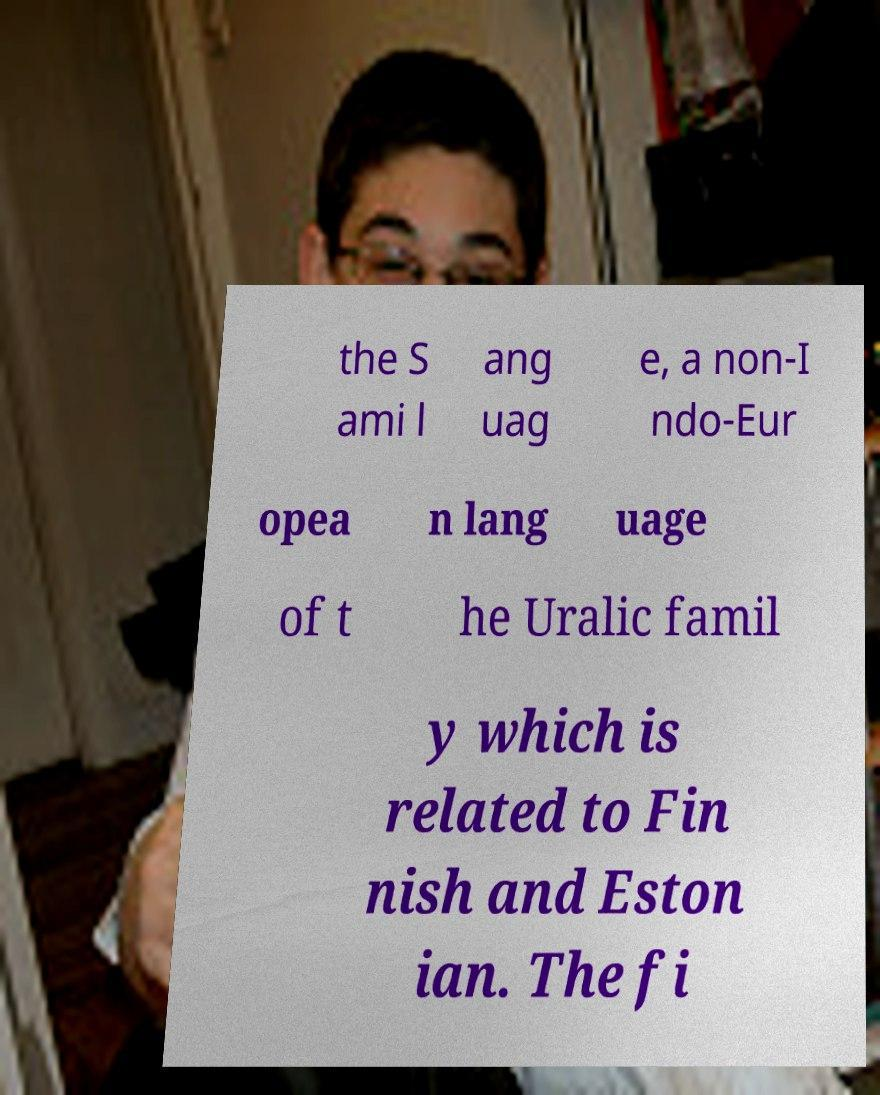Please read and relay the text visible in this image. What does it say? the S ami l ang uag e, a non-I ndo-Eur opea n lang uage of t he Uralic famil y which is related to Fin nish and Eston ian. The fi 